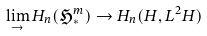Convert formula to latex. <formula><loc_0><loc_0><loc_500><loc_500>\lim _ { \rightarrow } H _ { n } ( \mathfrak { H } _ { * } ^ { m } ) \rightarrow H _ { n } ( H , L ^ { 2 } H )</formula> 